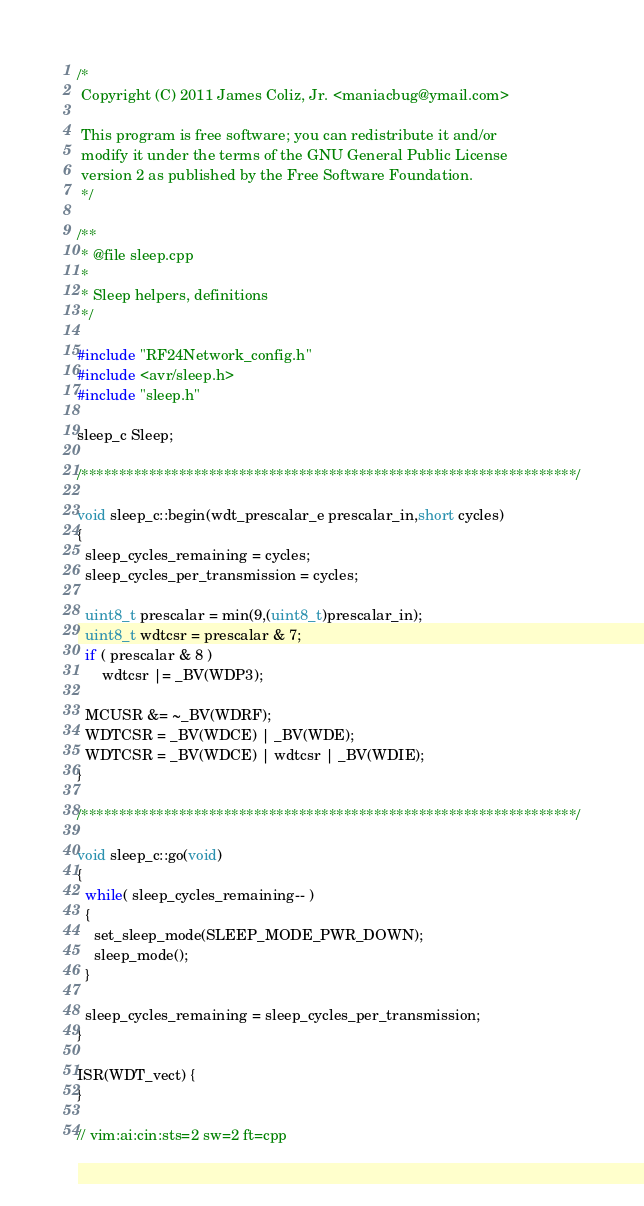Convert code to text. <code><loc_0><loc_0><loc_500><loc_500><_C++_>
/*
 Copyright (C) 2011 James Coliz, Jr. <maniacbug@ymail.com>
 
 This program is free software; you can redistribute it and/or
 modify it under the terms of the GNU General Public License
 version 2 as published by the Free Software Foundation.
 */

/**
 * @file sleep.cpp 
 *
 * Sleep helpers, definitions
 */

#include "RF24Network_config.h"
#include <avr/sleep.h>
#include "sleep.h" 

sleep_c Sleep;

/******************************************************************/

void sleep_c::begin(wdt_prescalar_e prescalar_in,short cycles)
{
  sleep_cycles_remaining = cycles;
  sleep_cycles_per_transmission = cycles;

  uint8_t prescalar = min(9,(uint8_t)prescalar_in);
  uint8_t wdtcsr = prescalar & 7;
  if ( prescalar & 8 )
      wdtcsr |= _BV(WDP3);

  MCUSR &= ~_BV(WDRF);
  WDTCSR = _BV(WDCE) | _BV(WDE);
  WDTCSR = _BV(WDCE) | wdtcsr | _BV(WDIE);
}

/******************************************************************/

void sleep_c::go(void)
{
  while( sleep_cycles_remaining-- )
  {
    set_sleep_mode(SLEEP_MODE_PWR_DOWN); 
    sleep_mode();
  }
  
  sleep_cycles_remaining = sleep_cycles_per_transmission;
}

ISR(WDT_vect) {
}

// vim:ai:cin:sts=2 sw=2 ft=cpp
</code> 